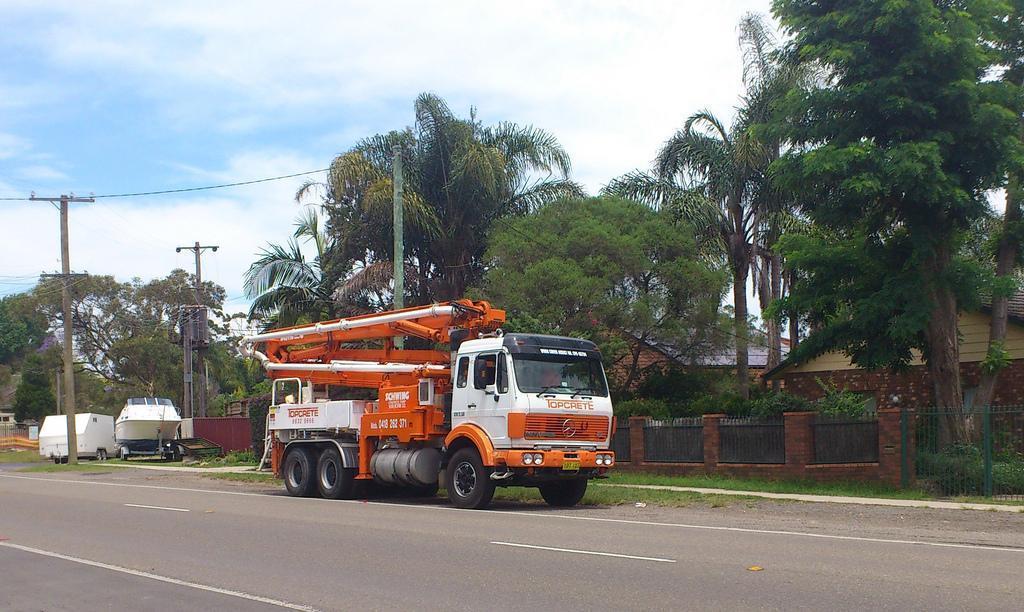How many trucks are pictured?
Give a very brief answer. 1. How many trucks are there?
Give a very brief answer. 1. How many utility poles are attached?
Give a very brief answer. 3. 